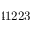<formula> <loc_0><loc_0><loc_500><loc_500>4 1 2 2 3</formula> 